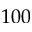Convert formula to latex. <formula><loc_0><loc_0><loc_500><loc_500>1 0 0</formula> 